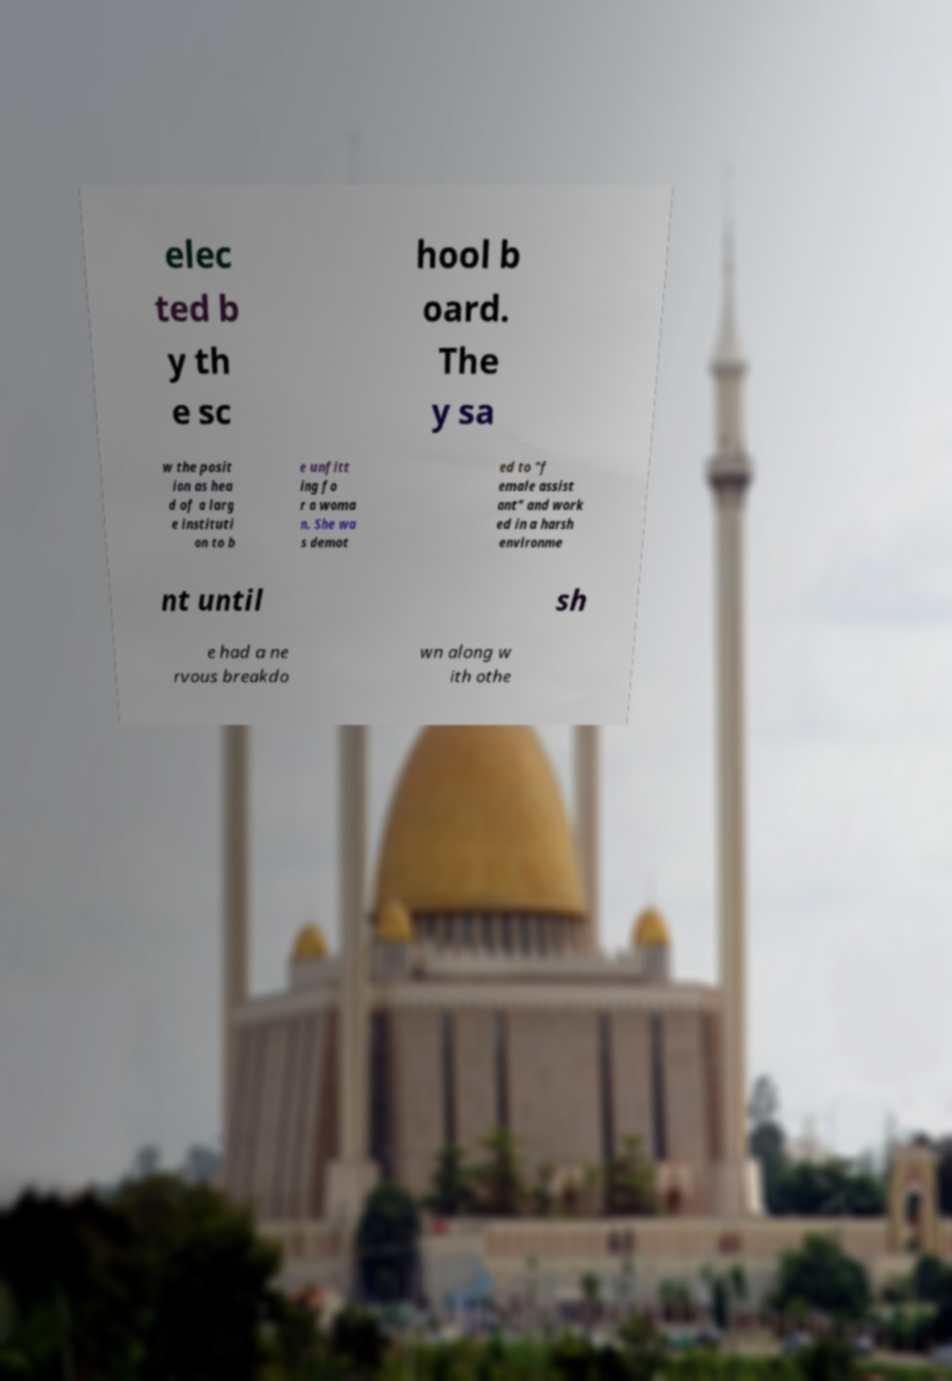Could you assist in decoding the text presented in this image and type it out clearly? elec ted b y th e sc hool b oard. The y sa w the posit ion as hea d of a larg e instituti on to b e unfitt ing fo r a woma n. She wa s demot ed to "f emale assist ant" and work ed in a harsh environme nt until sh e had a ne rvous breakdo wn along w ith othe 